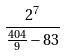<formula> <loc_0><loc_0><loc_500><loc_500>\frac { 2 ^ { 7 } } { \frac { 4 0 4 } { 9 } - 8 3 }</formula> 